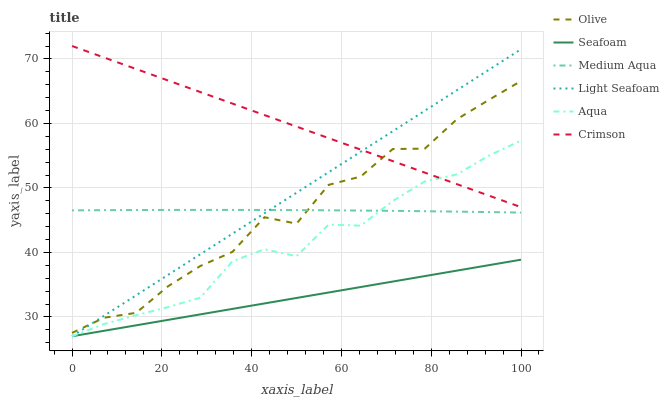Does Seafoam have the minimum area under the curve?
Answer yes or no. Yes. Does Crimson have the maximum area under the curve?
Answer yes or no. Yes. Does Crimson have the minimum area under the curve?
Answer yes or no. No. Does Seafoam have the maximum area under the curve?
Answer yes or no. No. Is Crimson the smoothest?
Answer yes or no. Yes. Is Olive the roughest?
Answer yes or no. Yes. Is Seafoam the smoothest?
Answer yes or no. No. Is Seafoam the roughest?
Answer yes or no. No. Does Crimson have the lowest value?
Answer yes or no. No. Does Seafoam have the highest value?
Answer yes or no. No. Is Medium Aqua less than Crimson?
Answer yes or no. Yes. Is Olive greater than Aqua?
Answer yes or no. Yes. Does Medium Aqua intersect Crimson?
Answer yes or no. No. 